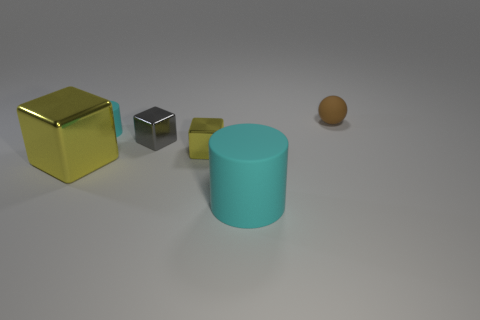The other block that is the same color as the large block is what size?
Keep it short and to the point. Small. How many other matte things are the same shape as the big matte object?
Keep it short and to the point. 1. What shape is the tiny rubber object that is the same color as the big cylinder?
Your answer should be very brief. Cylinder. Are there any other things that are the same color as the large shiny object?
Make the answer very short. Yes. There is a cyan cylinder to the left of the large cyan object; what size is it?
Your answer should be compact. Small. Is the number of big objects greater than the number of tiny objects?
Provide a succinct answer. No. What is the big cylinder made of?
Provide a succinct answer. Rubber. How many other things are there of the same material as the large cyan cylinder?
Ensure brevity in your answer.  2. What number of blue metallic spheres are there?
Your answer should be compact. 0. What material is the other yellow object that is the same shape as the small yellow thing?
Your response must be concise. Metal. 